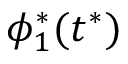<formula> <loc_0><loc_0><loc_500><loc_500>\phi _ { 1 } ^ { * } ( t ^ { * } )</formula> 